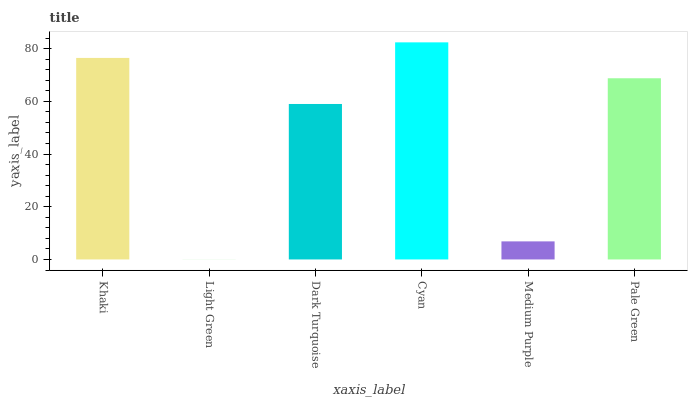Is Dark Turquoise the minimum?
Answer yes or no. No. Is Dark Turquoise the maximum?
Answer yes or no. No. Is Dark Turquoise greater than Light Green?
Answer yes or no. Yes. Is Light Green less than Dark Turquoise?
Answer yes or no. Yes. Is Light Green greater than Dark Turquoise?
Answer yes or no. No. Is Dark Turquoise less than Light Green?
Answer yes or no. No. Is Pale Green the high median?
Answer yes or no. Yes. Is Dark Turquoise the low median?
Answer yes or no. Yes. Is Cyan the high median?
Answer yes or no. No. Is Pale Green the low median?
Answer yes or no. No. 